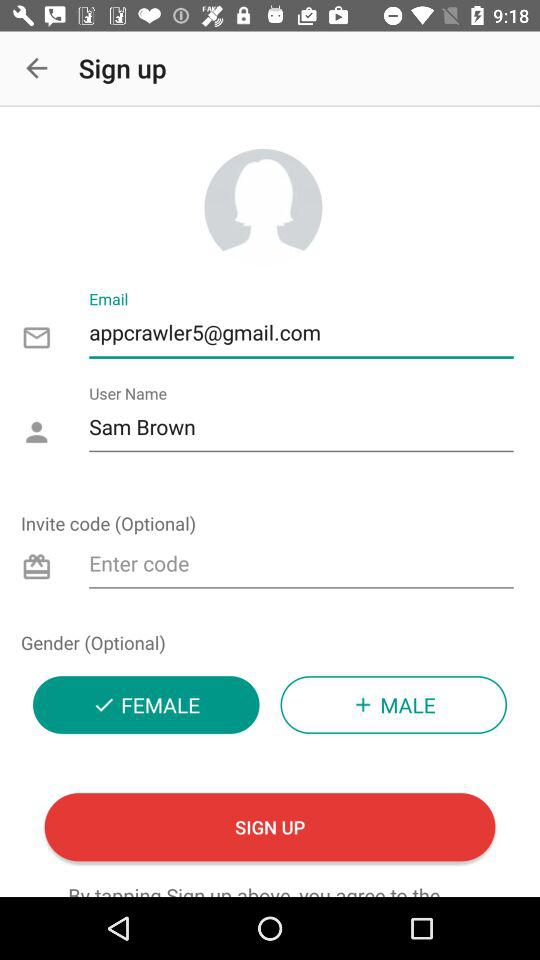Which gender has selected? The selected gender is female. 